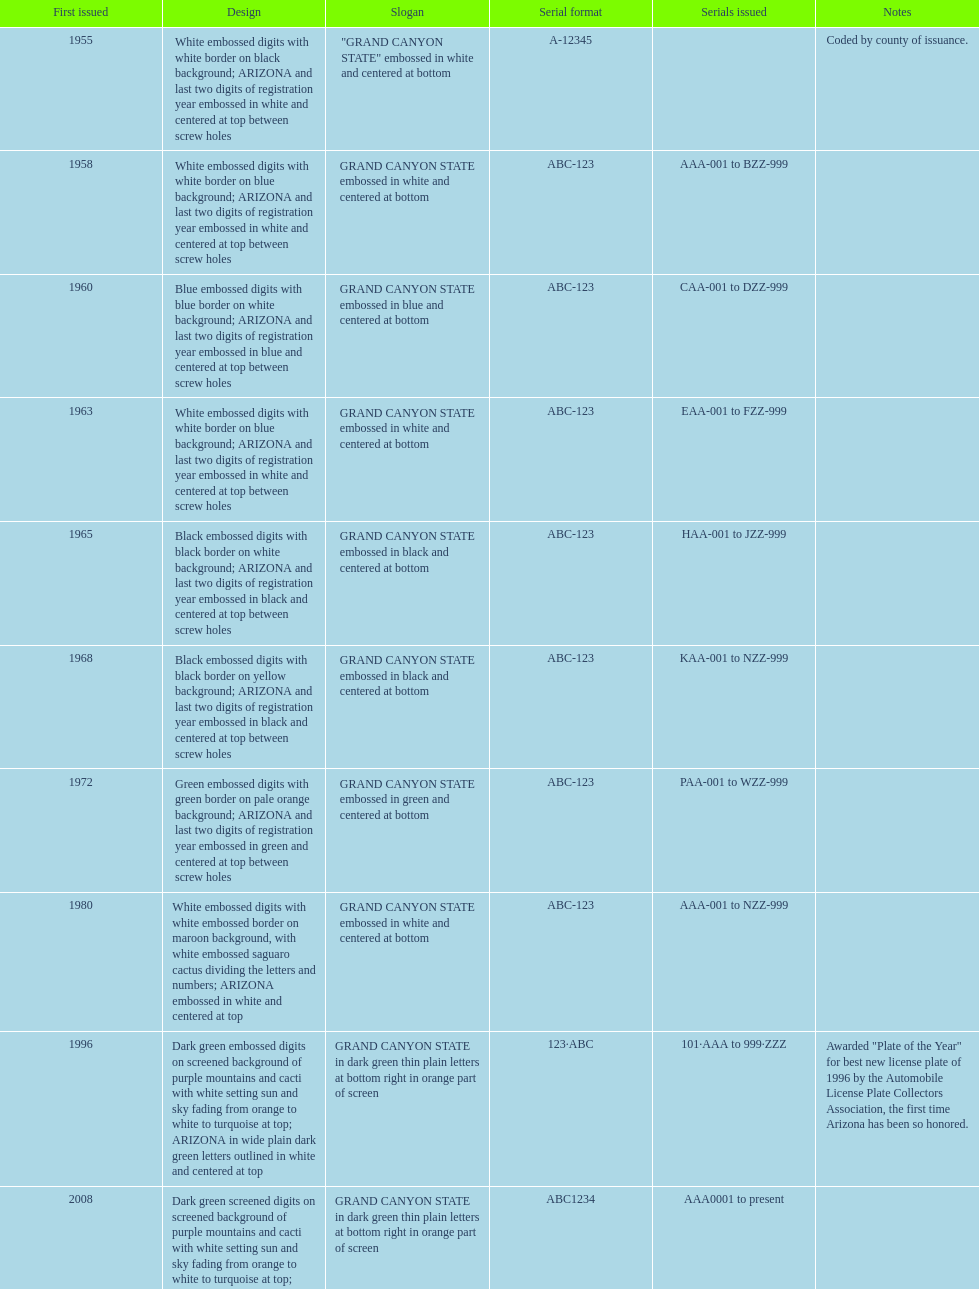In which year was the license plate with the maximum alphanumeric digits issued? 2008. 